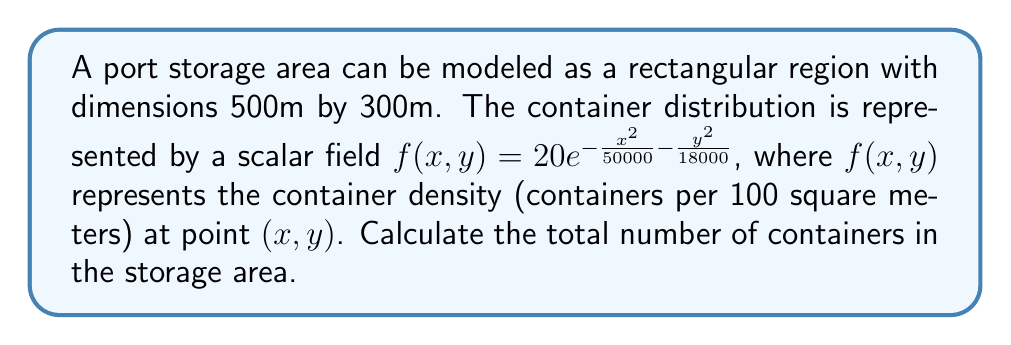Can you answer this question? To solve this problem, we need to integrate the scalar field over the given region. Here's a step-by-step approach:

1) The total number of containers is given by the volume under the surface $f(x,y)$ over the rectangular region.

2) We need to set up a double integral:

   $$N = \int_{-250}^{250} \int_{-150}^{150} f(x,y) \, dy \, dx$$

3) Substitute the given function:

   $$N = \int_{-250}^{250} \int_{-150}^{150} 20e^{-\frac{x^2}{50000} - \frac{y^2}{18000}} \, dy \, dx$$

4) This integral is separable. Let's solve it step by step:

   $$N = 20 \int_{-250}^{250} e^{-\frac{x^2}{50000}} \, dx \int_{-150}^{150} e^{-\frac{y^2}{18000}} \, dy$$

5) For the y-integral:
   
   $$\int_{-150}^{150} e^{-\frac{y^2}{18000}} \, dy = \sqrt{18000\pi} \, \text{erf}\left(\frac{150}{\sqrt{18000}}\right)$$

6) For the x-integral:

   $$\int_{-250}^{250} e^{-\frac{x^2}{50000}} \, dx = \sqrt{50000\pi} \, \text{erf}\left(\frac{250}{\sqrt{50000}}\right)$$

7) Multiplying these results:

   $$N = 20 \cdot \sqrt{18000\pi} \, \text{erf}\left(\frac{150}{\sqrt{18000}}\right) \cdot \sqrt{50000\pi} \, \text{erf}\left(\frac{250}{\sqrt{50000}}\right)$$

8) Simplify:

   $$N = 20 \sqrt{900000000\pi^2} \, \text{erf}(1.118) \, \text{erf}(1.118)$$

9) Calculate the numeric value:

   $$N \approx 2991.6$$

10) Since we're counting containers, we round to the nearest whole number.
Answer: 2992 containers 